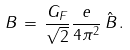<formula> <loc_0><loc_0><loc_500><loc_500>B \, = \, \frac { G _ { F } } { \sqrt { 2 } } \frac { e } { 4 \pi ^ { 2 } } \, \hat { B } \, .</formula> 